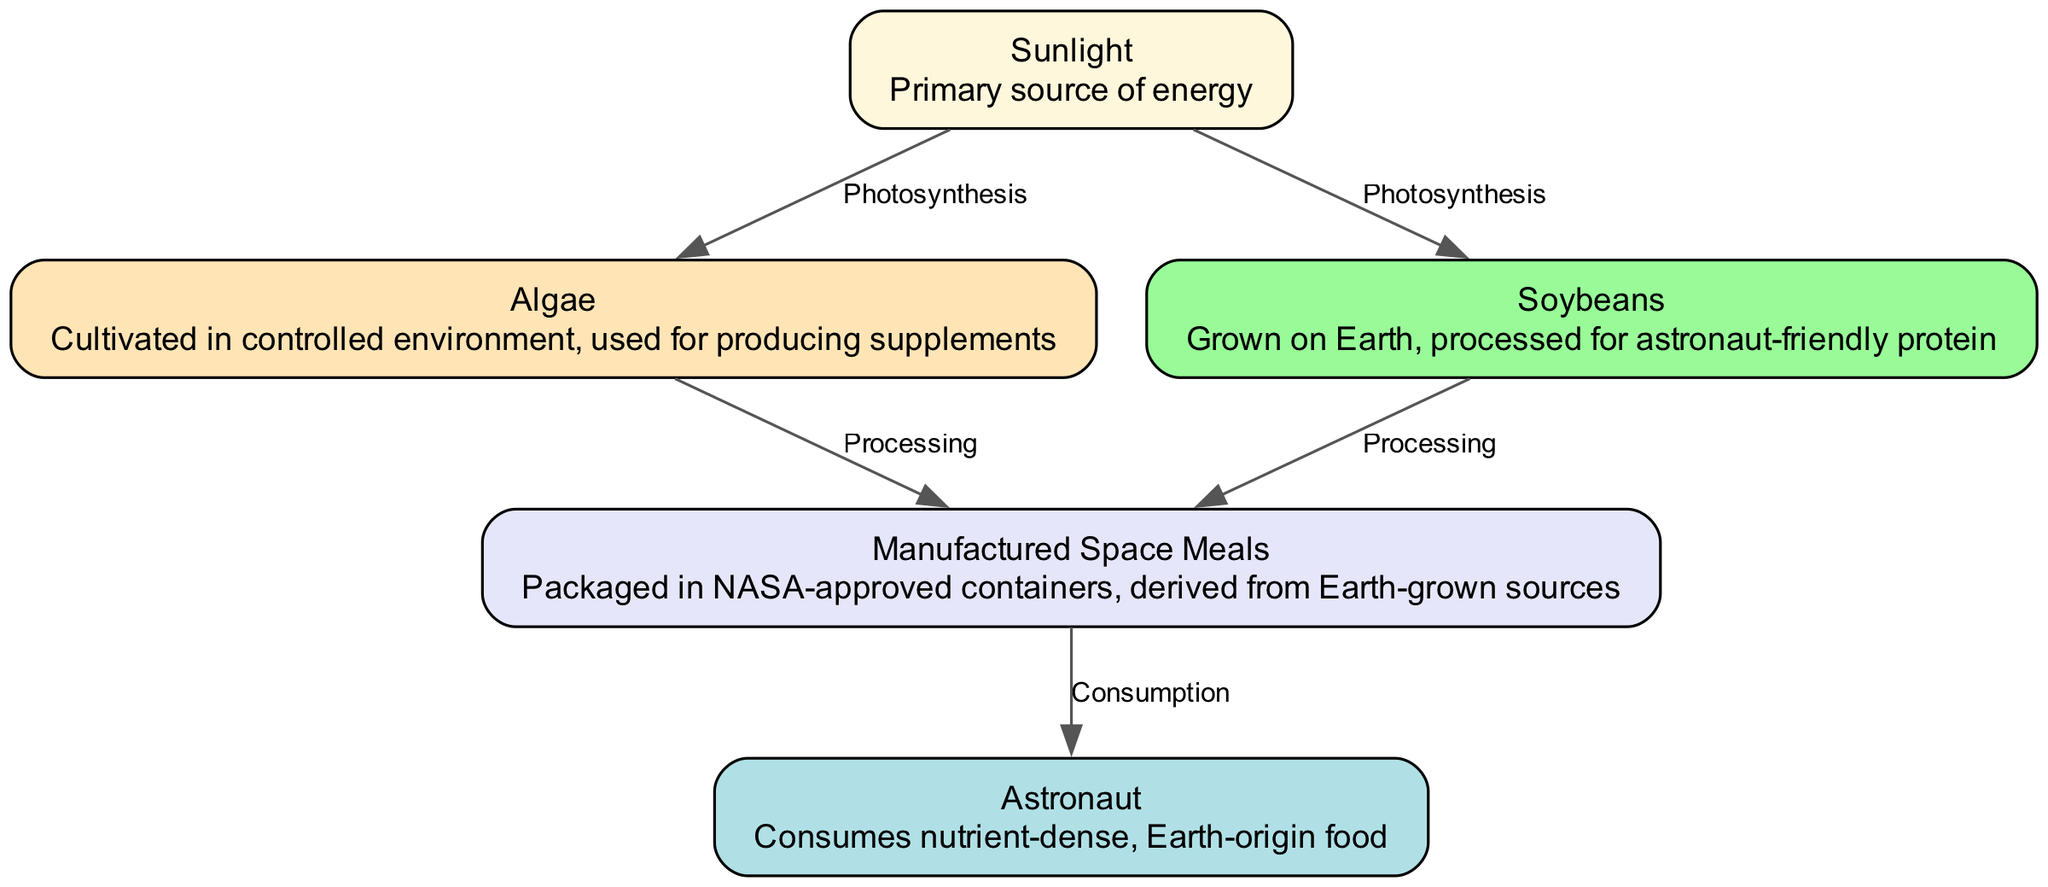What is the primary source of energy in this food chain? The diagram starts with "Sunlight," which is labeled as the "Primary source of energy." Hence, it is the first node and the main energy input for the entire chain.
Answer: Sunlight How many nodes are present in the diagram? Counting each unique element in the food chain, there are five distinct nodes: Sunlight, Algae, Soybeans, Manufactured Space Meals, and Astronaut. Therefore, the total is five.
Answer: 5 What is the relationship between Sunlight and Algae? The diagram shows an edge connecting Sunlight to Algae, labeled "Photosynthesis." This indicates that Algae relies on Sunlight for its growth through the process of photosynthesis.
Answer: Photosynthesis What food source directly contributes to the Manufactured Space Meals? The edge connecting Algae and Soybeans to Manufactured Space Meals signifies that both sources contribute. However, since the question asks for a specific source, Algae can be highlighted as one contributor while Soybeans is also valid.
Answer: Algae Who consumes the nutrient-dense food derived from Earth? The final step in the diagram points to "Astronaut," which indicates that the Astronaut consumes the nutrient-dense food that originated from Earth-grown sources.
Answer: Astronaut How does Soybeans contribute to the food chain? The diagram indicates an edge from Soybeans to Manufactured Space Meals with the label "Processing." This implies that Soybeans are processed to create meals that can be consumed by Astronauts.
Answer: Processing What is the processing step before consumption? The arrow labeled "Processing" connects both Algae and Soybeans to Manufactured Space Meals, indicating that these items undergo processing before being consumed by the Astronauts. Thus, the processing is at the Manufactured Space Meals stage.
Answer: Processing Which node results directly from the processing of both Algae and Soybeans? According to the relationships illustrated, both Algae and Soybeans lead to the "Manufactured Space Meals" node through their respective processing steps. Thus, the direct result of this processing is the meals.
Answer: Manufactured Space Meals 